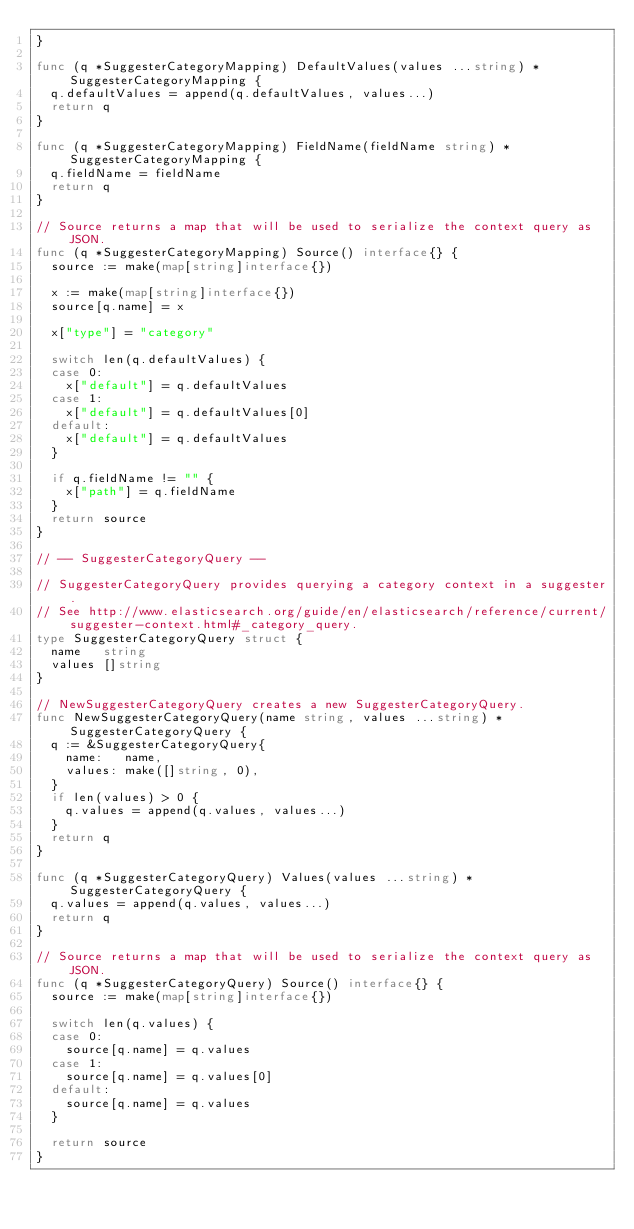Convert code to text. <code><loc_0><loc_0><loc_500><loc_500><_Go_>}

func (q *SuggesterCategoryMapping) DefaultValues(values ...string) *SuggesterCategoryMapping {
	q.defaultValues = append(q.defaultValues, values...)
	return q
}

func (q *SuggesterCategoryMapping) FieldName(fieldName string) *SuggesterCategoryMapping {
	q.fieldName = fieldName
	return q
}

// Source returns a map that will be used to serialize the context query as JSON.
func (q *SuggesterCategoryMapping) Source() interface{} {
	source := make(map[string]interface{})

	x := make(map[string]interface{})
	source[q.name] = x

	x["type"] = "category"

	switch len(q.defaultValues) {
	case 0:
		x["default"] = q.defaultValues
	case 1:
		x["default"] = q.defaultValues[0]
	default:
		x["default"] = q.defaultValues
	}

	if q.fieldName != "" {
		x["path"] = q.fieldName
	}
	return source
}

// -- SuggesterCategoryQuery --

// SuggesterCategoryQuery provides querying a category context in a suggester.
// See http://www.elasticsearch.org/guide/en/elasticsearch/reference/current/suggester-context.html#_category_query.
type SuggesterCategoryQuery struct {
	name   string
	values []string
}

// NewSuggesterCategoryQuery creates a new SuggesterCategoryQuery.
func NewSuggesterCategoryQuery(name string, values ...string) *SuggesterCategoryQuery {
	q := &SuggesterCategoryQuery{
		name:   name,
		values: make([]string, 0),
	}
	if len(values) > 0 {
		q.values = append(q.values, values...)
	}
	return q
}

func (q *SuggesterCategoryQuery) Values(values ...string) *SuggesterCategoryQuery {
	q.values = append(q.values, values...)
	return q
}

// Source returns a map that will be used to serialize the context query as JSON.
func (q *SuggesterCategoryQuery) Source() interface{} {
	source := make(map[string]interface{})

	switch len(q.values) {
	case 0:
		source[q.name] = q.values
	case 1:
		source[q.name] = q.values[0]
	default:
		source[q.name] = q.values
	}

	return source
}
</code> 